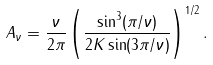Convert formula to latex. <formula><loc_0><loc_0><loc_500><loc_500>A _ { \nu } = \frac { \nu } { 2 \pi } \left ( \frac { \sin ^ { 3 } ( \pi / \nu ) } { 2 K \sin ( 3 \pi / \nu ) } \right ) ^ { 1 / 2 } .</formula> 